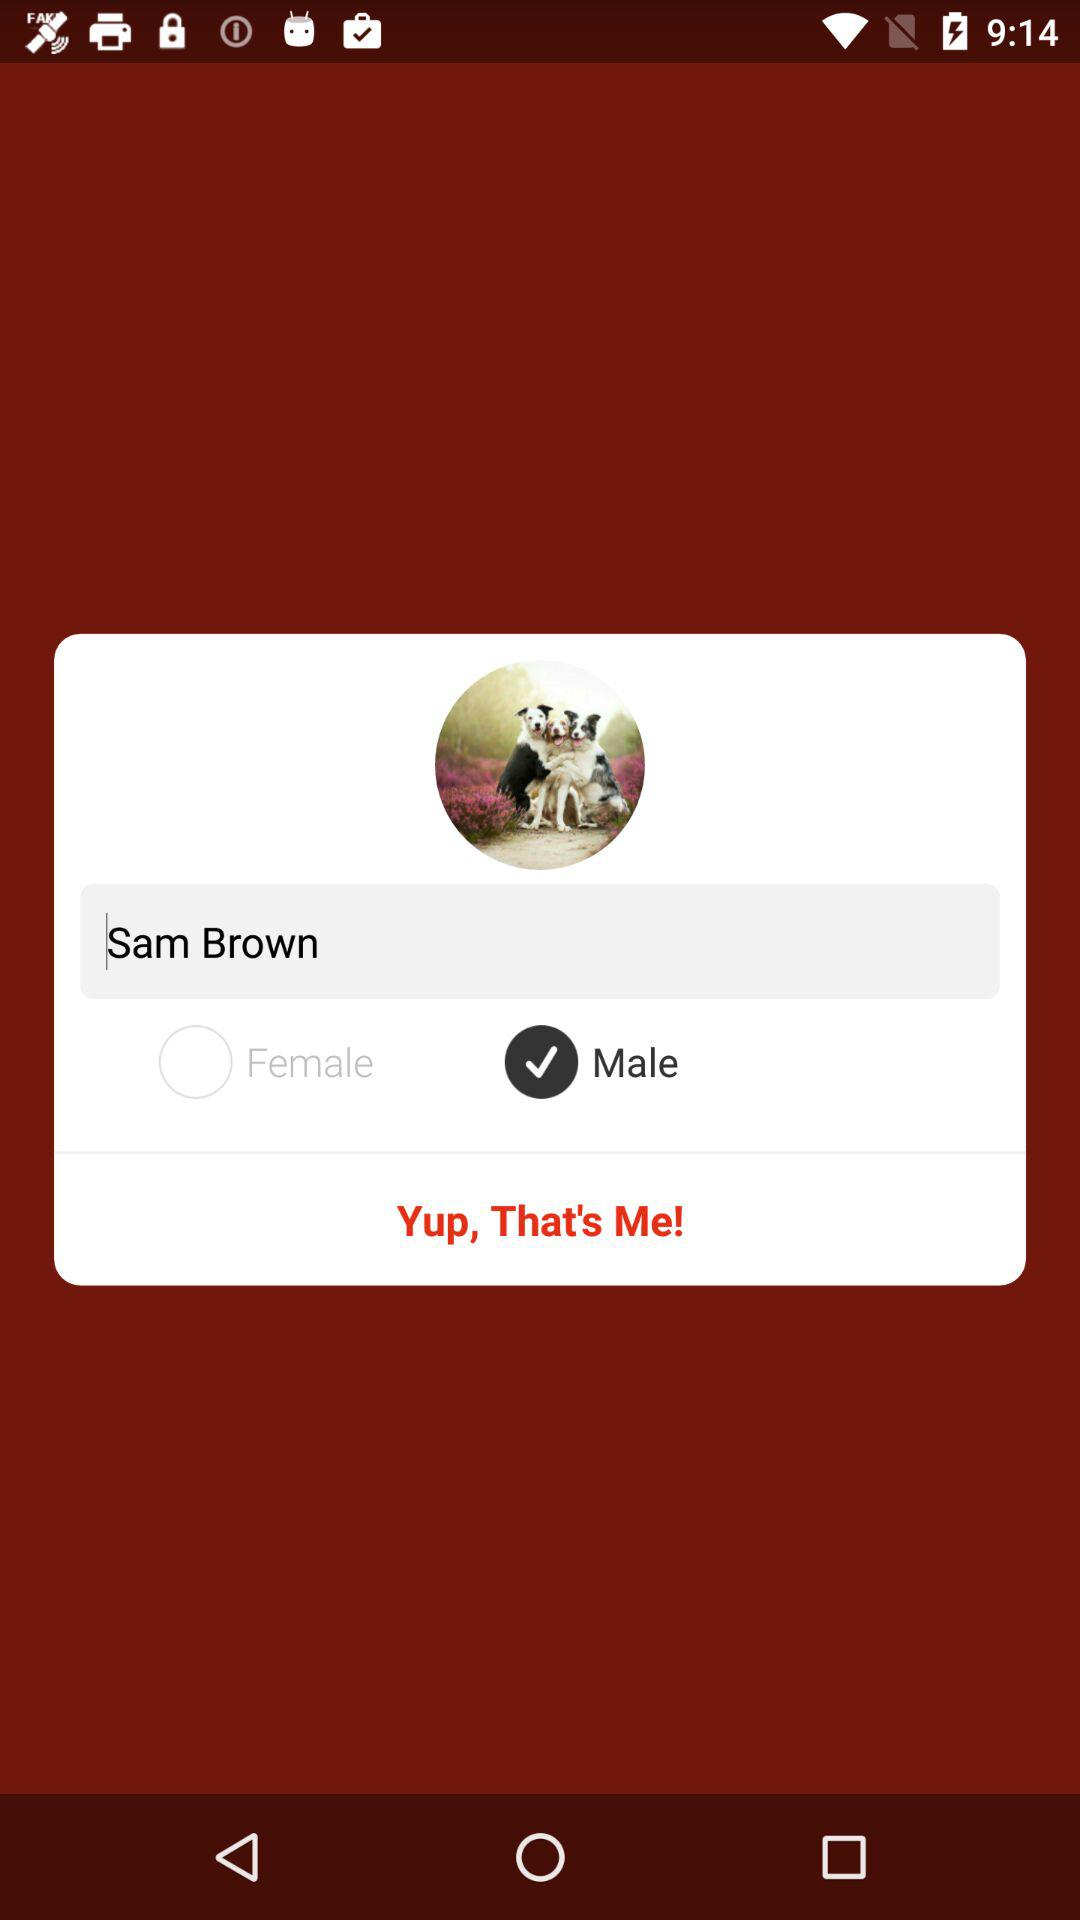Which email has been confirmed?
When the provided information is insufficient, respond with <no answer>. <no answer> 